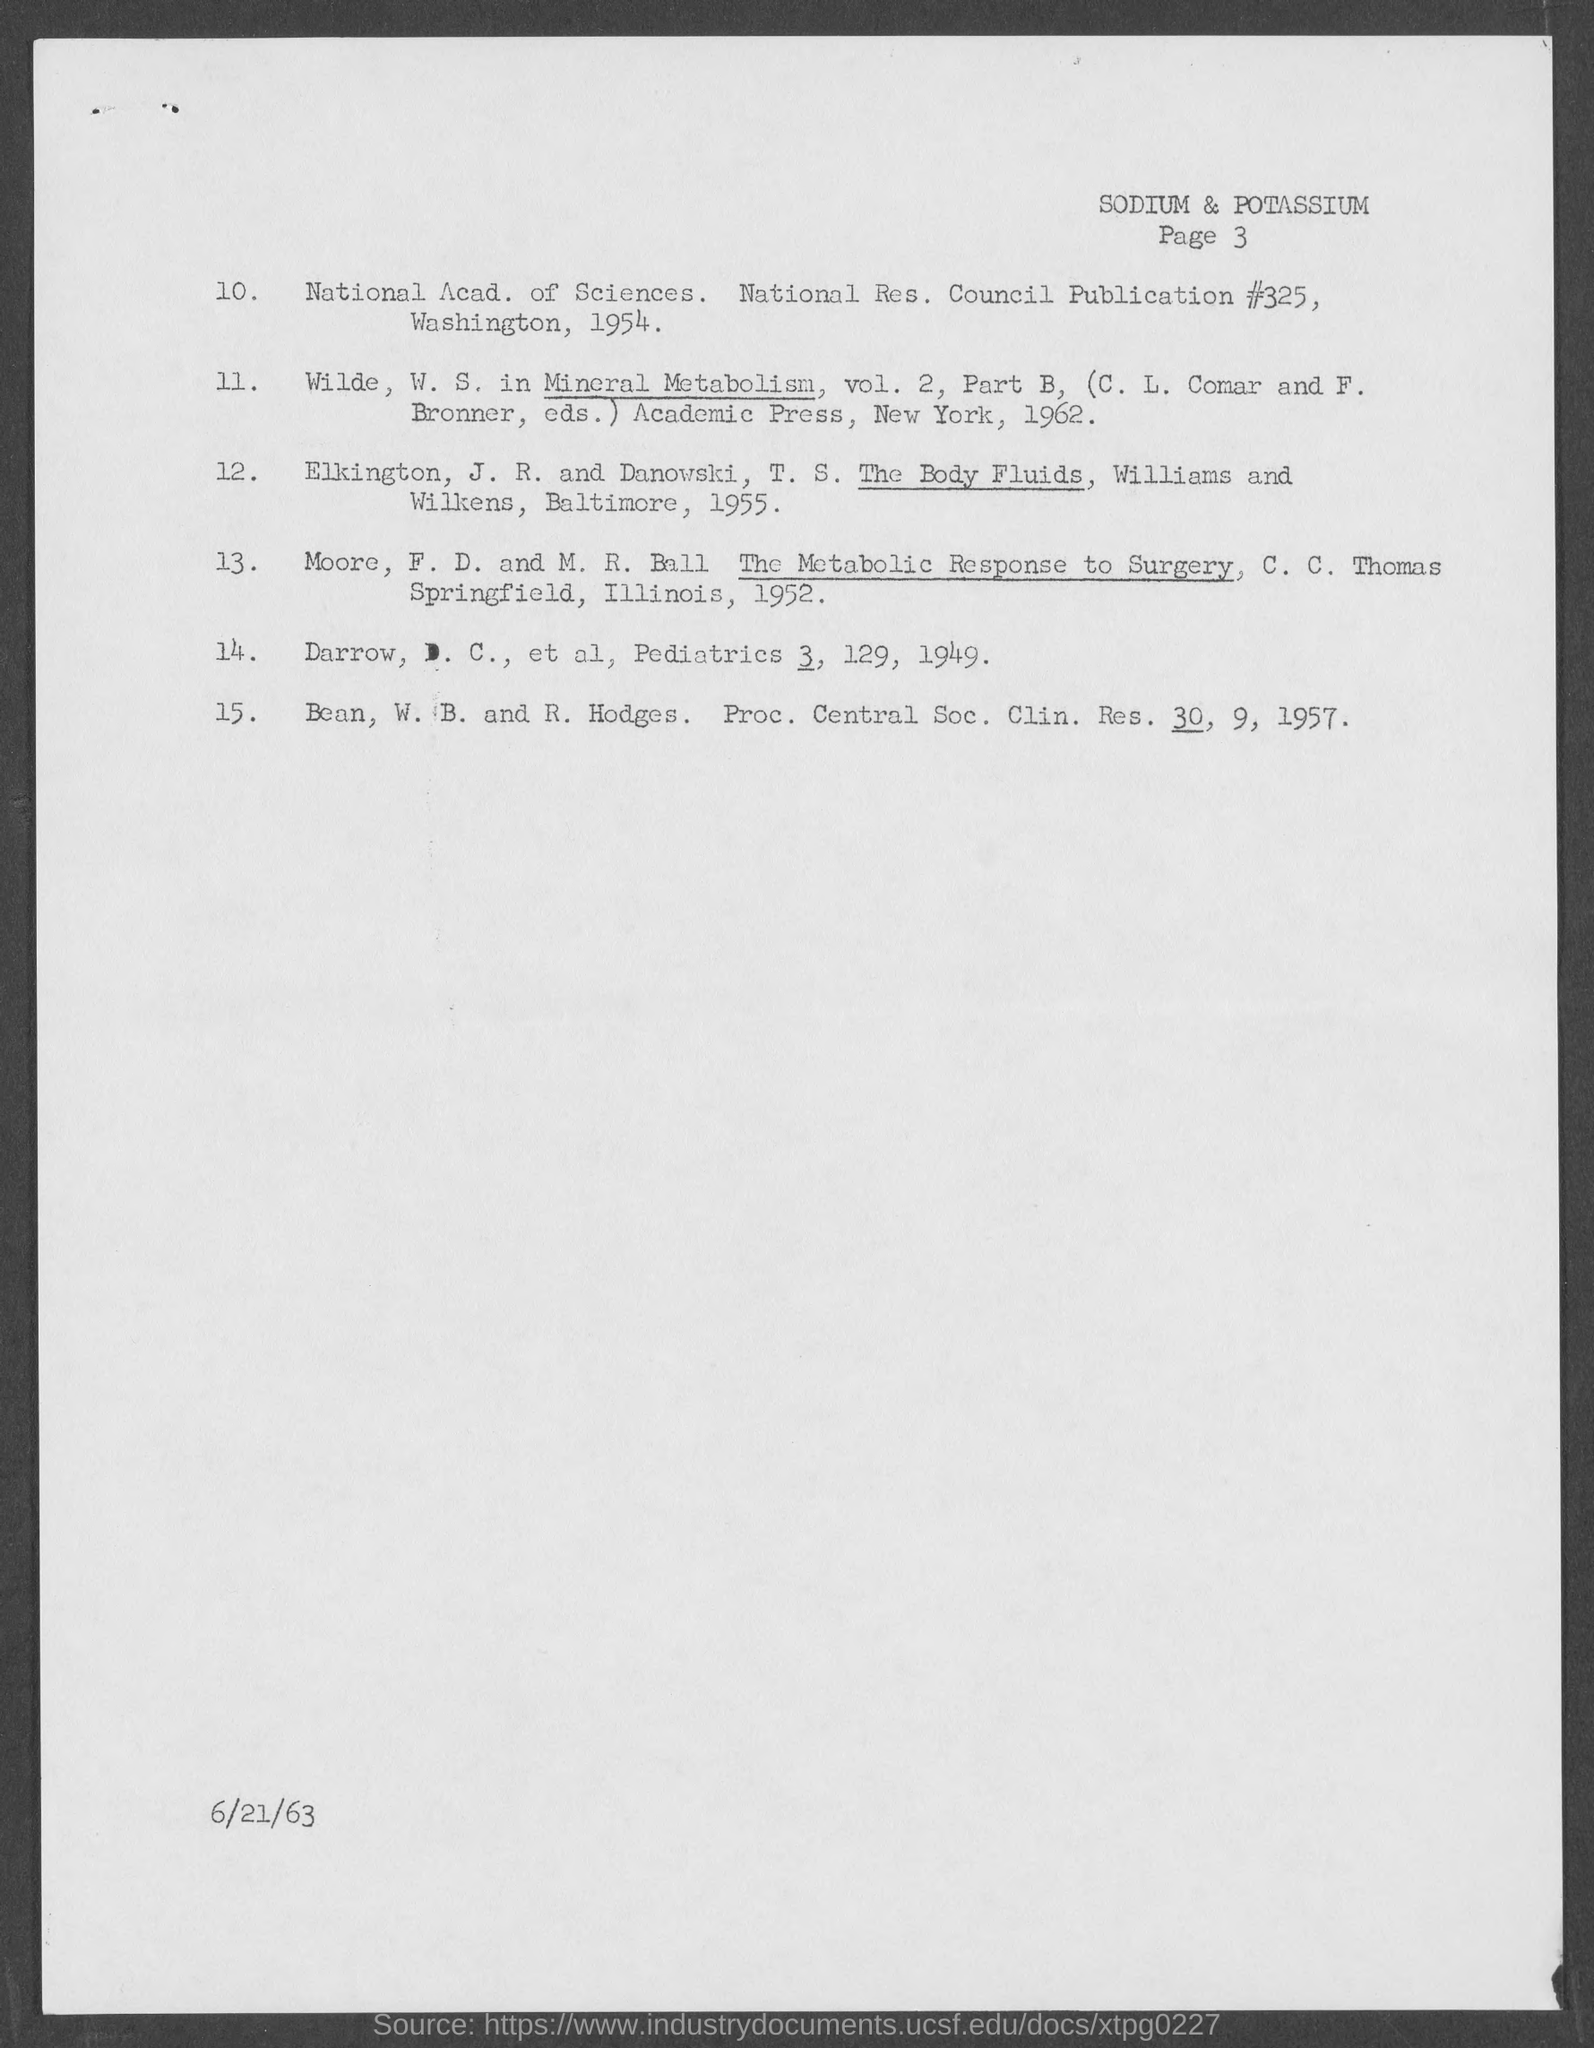Mention a couple of crucial points in this snapshot. The page number at the top of the page is 3. The date at the bottom of the page is 6/21/63. 